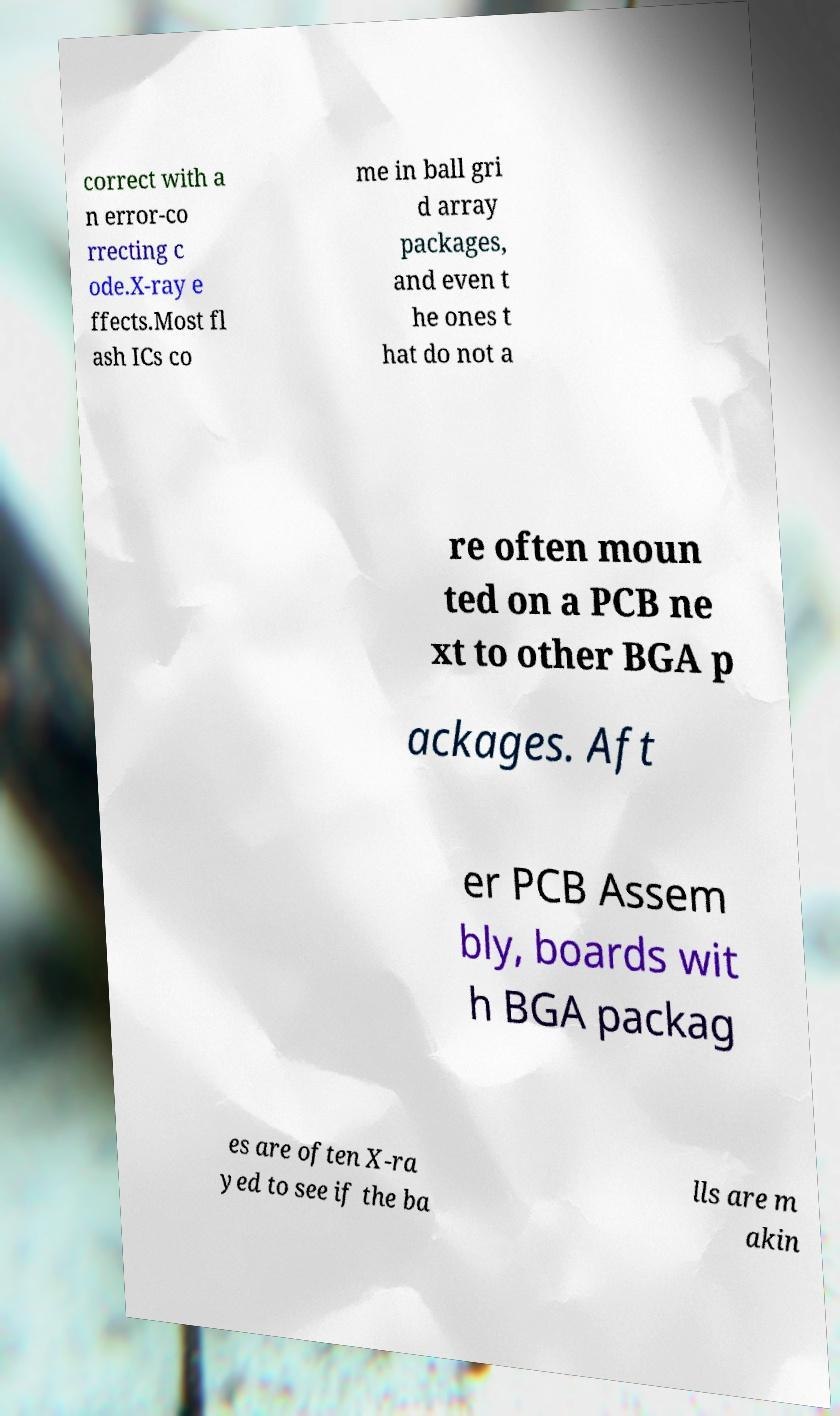Could you extract and type out the text from this image? correct with a n error-co rrecting c ode.X-ray e ffects.Most fl ash ICs co me in ball gri d array packages, and even t he ones t hat do not a re often moun ted on a PCB ne xt to other BGA p ackages. Aft er PCB Assem bly, boards wit h BGA packag es are often X-ra yed to see if the ba lls are m akin 